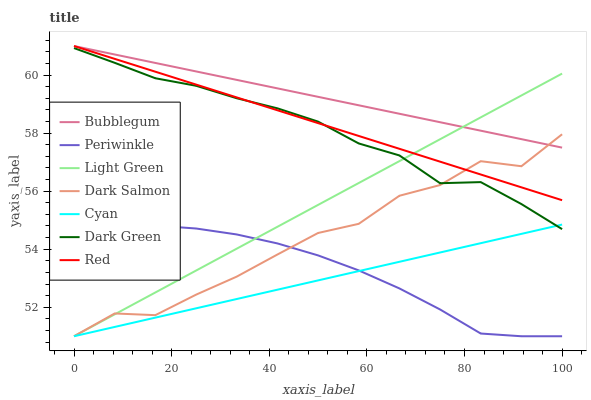Does Cyan have the minimum area under the curve?
Answer yes or no. Yes. Does Periwinkle have the minimum area under the curve?
Answer yes or no. No. Does Periwinkle have the maximum area under the curve?
Answer yes or no. No. Is Dark Salmon the roughest?
Answer yes or no. Yes. Is Bubblegum the smoothest?
Answer yes or no. No. Is Bubblegum the roughest?
Answer yes or no. No. Does Bubblegum have the lowest value?
Answer yes or no. No. Does Periwinkle have the highest value?
Answer yes or no. No. Is Cyan less than Red?
Answer yes or no. Yes. Is Bubblegum greater than Cyan?
Answer yes or no. Yes. Does Cyan intersect Red?
Answer yes or no. No. 